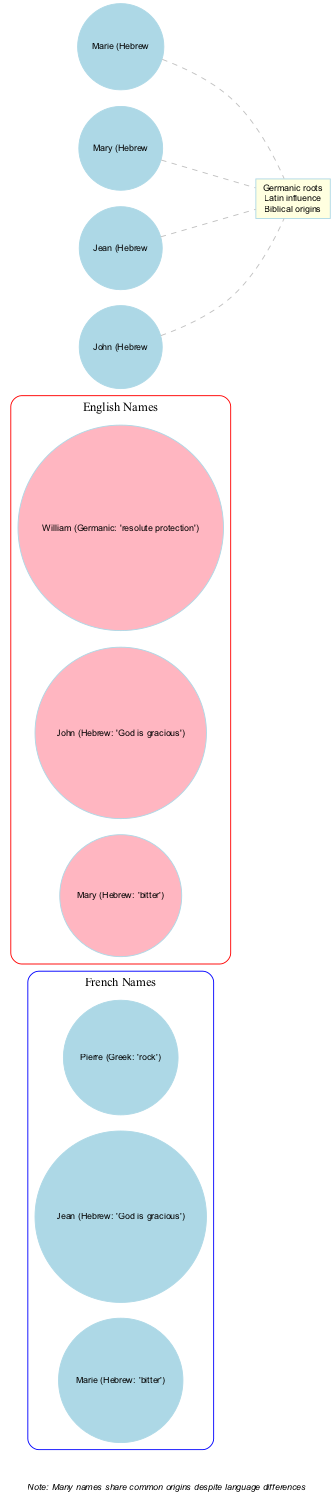What are the three French names listed in the diagram? The diagram lists the French names Marie, Jean, and Pierre in the French Names circle.
Answer: Marie, Jean, Pierre Which English name has biblical origins? Both Mary and John have biblical origins that are indicated in the intersection of the diagram. However, to answer the question, we can specifically point out that Mary is an English name with biblical origins.
Answer: Mary How many names share a common Hebrew origin? Looking at the intersections, both Marie and Mary share the common Hebrew origin meaning 'bitter', while Jean and John both mean 'God is gracious'. Therefore, the total number is four names.
Answer: Four Which name in English is derived from Germanic roots? According to the circles, William is noted in the English names for having Germanic origins. The intersection mentions common Germanic roots, but only William in the English list is specifically attributed to Germanic.
Answer: William What makes the names Marie and Mary similar? Both names are listed in their respective sections (French and English), with the same Hebrew origin meaning 'bitter', which is emphasized at their connection to the intersection.
Answer: Biblical origins What is the primary theme represented in the intersection of the Venn diagram? The intersection includes 'Germanic roots', 'Latin influence', and 'Biblical origins', which indicate the primary theme of shared linguistic heritage among the names.
Answer: Shared origins How many names are in the English section of the diagram? The English Names circle contains three names: Mary, John, and William, which can be counted directly from the elements listed in that section.
Answer: Three What is the significance of the note at the bottom of the diagram? The note points out that many names share common origins despite differences in language, highlighting the interconnectedness of the names listed in the diagram.
Answer: Common origins What color represents the French Names in the Venn diagram? The French Names circle is represented in blue, as can be seen in the subgraph settings for that circle.
Answer: Blue What is the origin of the name Pierre? The diagram indicates that Pierre has Greek origins, specifically meaning 'rock'. This is stated in the French names section.
Answer: Greek 